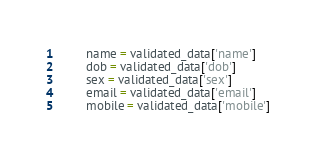<code> <loc_0><loc_0><loc_500><loc_500><_Python_>		name = validated_data['name']
		dob = validated_data['dob']
		sex = validated_data['sex']
		email = validated_data['email']
		mobile = validated_data['mobile']</code> 